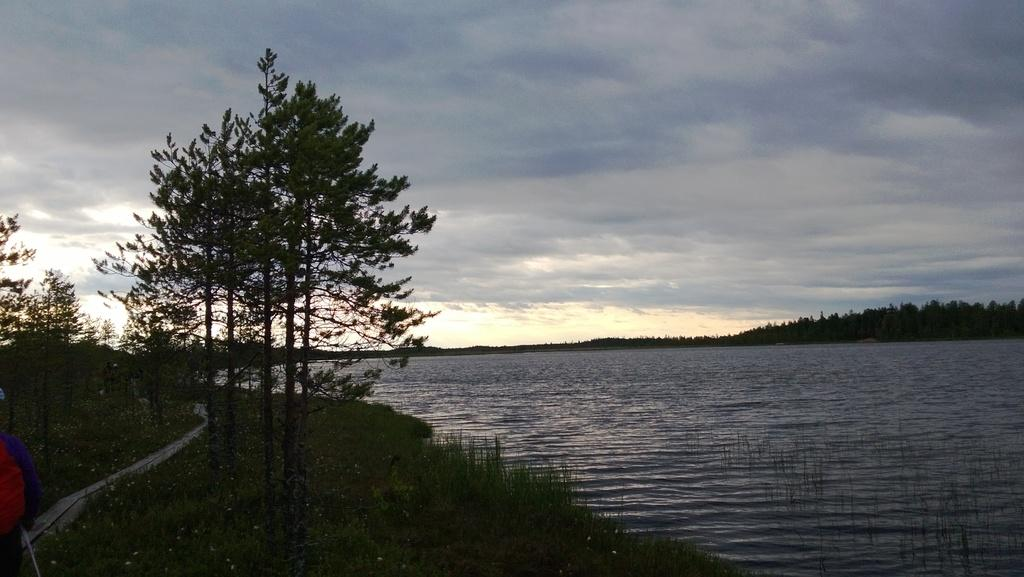What type of vegetation can be seen in the image? There are trees and plants visible in the image. What natural element is visible in the image? There is water visible in the image. What is visible in the background of the image? The sky is visible in the background of the image. What can be seen in the sky in the image? There are clouds in the sky. What color is the hair on the tree in the image? There is no hair present on the trees in the image, as trees are plants and do not have hair. How does the net help the eye in the image? There is no eye or net present in the image. 